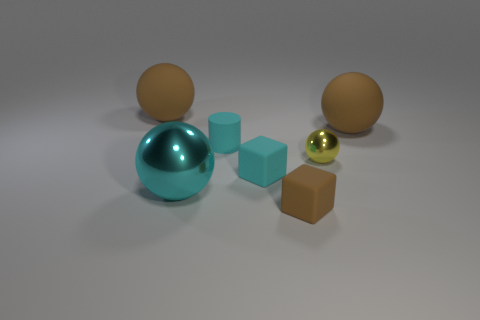How does the arrangement of the objects create a sense of balance or composition? The arrangement of objects in the image presents a visually pleasing asymmetry that balances the image composition. On the left, there's a cluster of objects with varying heights and sizes, which draws the viewer's eye across the scene. The positioning of the larger teal ball, flanked by the two brown balls, anchors the composition, while the smaller blocks and yellow ball add interest and keep the viewer's gaze moving around the scene. The careful spacing between the objects also contributes to a harmonious balance without making the scene feel overly crowded. 